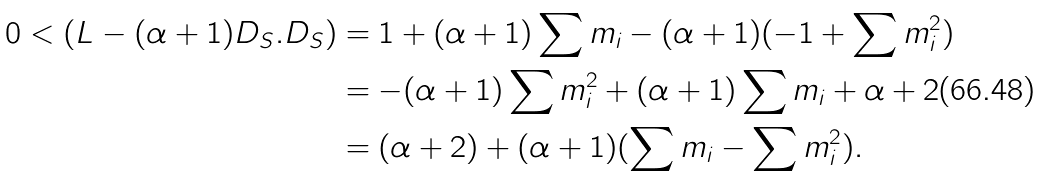<formula> <loc_0><loc_0><loc_500><loc_500>0 < ( L - ( \alpha + 1 ) D _ { S } . D _ { S } ) & = 1 + ( \alpha + 1 ) \sum m _ { i } - ( \alpha + 1 ) ( - 1 + \sum m _ { i } ^ { 2 } ) \\ & = - ( \alpha + 1 ) \sum m _ { i } ^ { 2 } + ( \alpha + 1 ) \sum m _ { i } + \alpha + 2 \\ & = ( \alpha + 2 ) + ( \alpha + 1 ) ( \sum m _ { i } - \sum m _ { i } ^ { 2 } ) .</formula> 